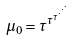<formula> <loc_0><loc_0><loc_500><loc_500>\mu _ { 0 } = \tau ^ { \tau ^ { \tau ^ { \cdot ^ { \cdot ^ { \cdot } } } } }</formula> 